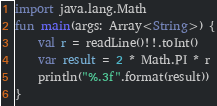<code> <loc_0><loc_0><loc_500><loc_500><_Kotlin_>import java.lang.Math
fun main(args: Array<String>) {
    val r = readLine()!!.toInt()
    var result = 2 * Math.PI * r
    println("%.3f".format(result))
}</code> 